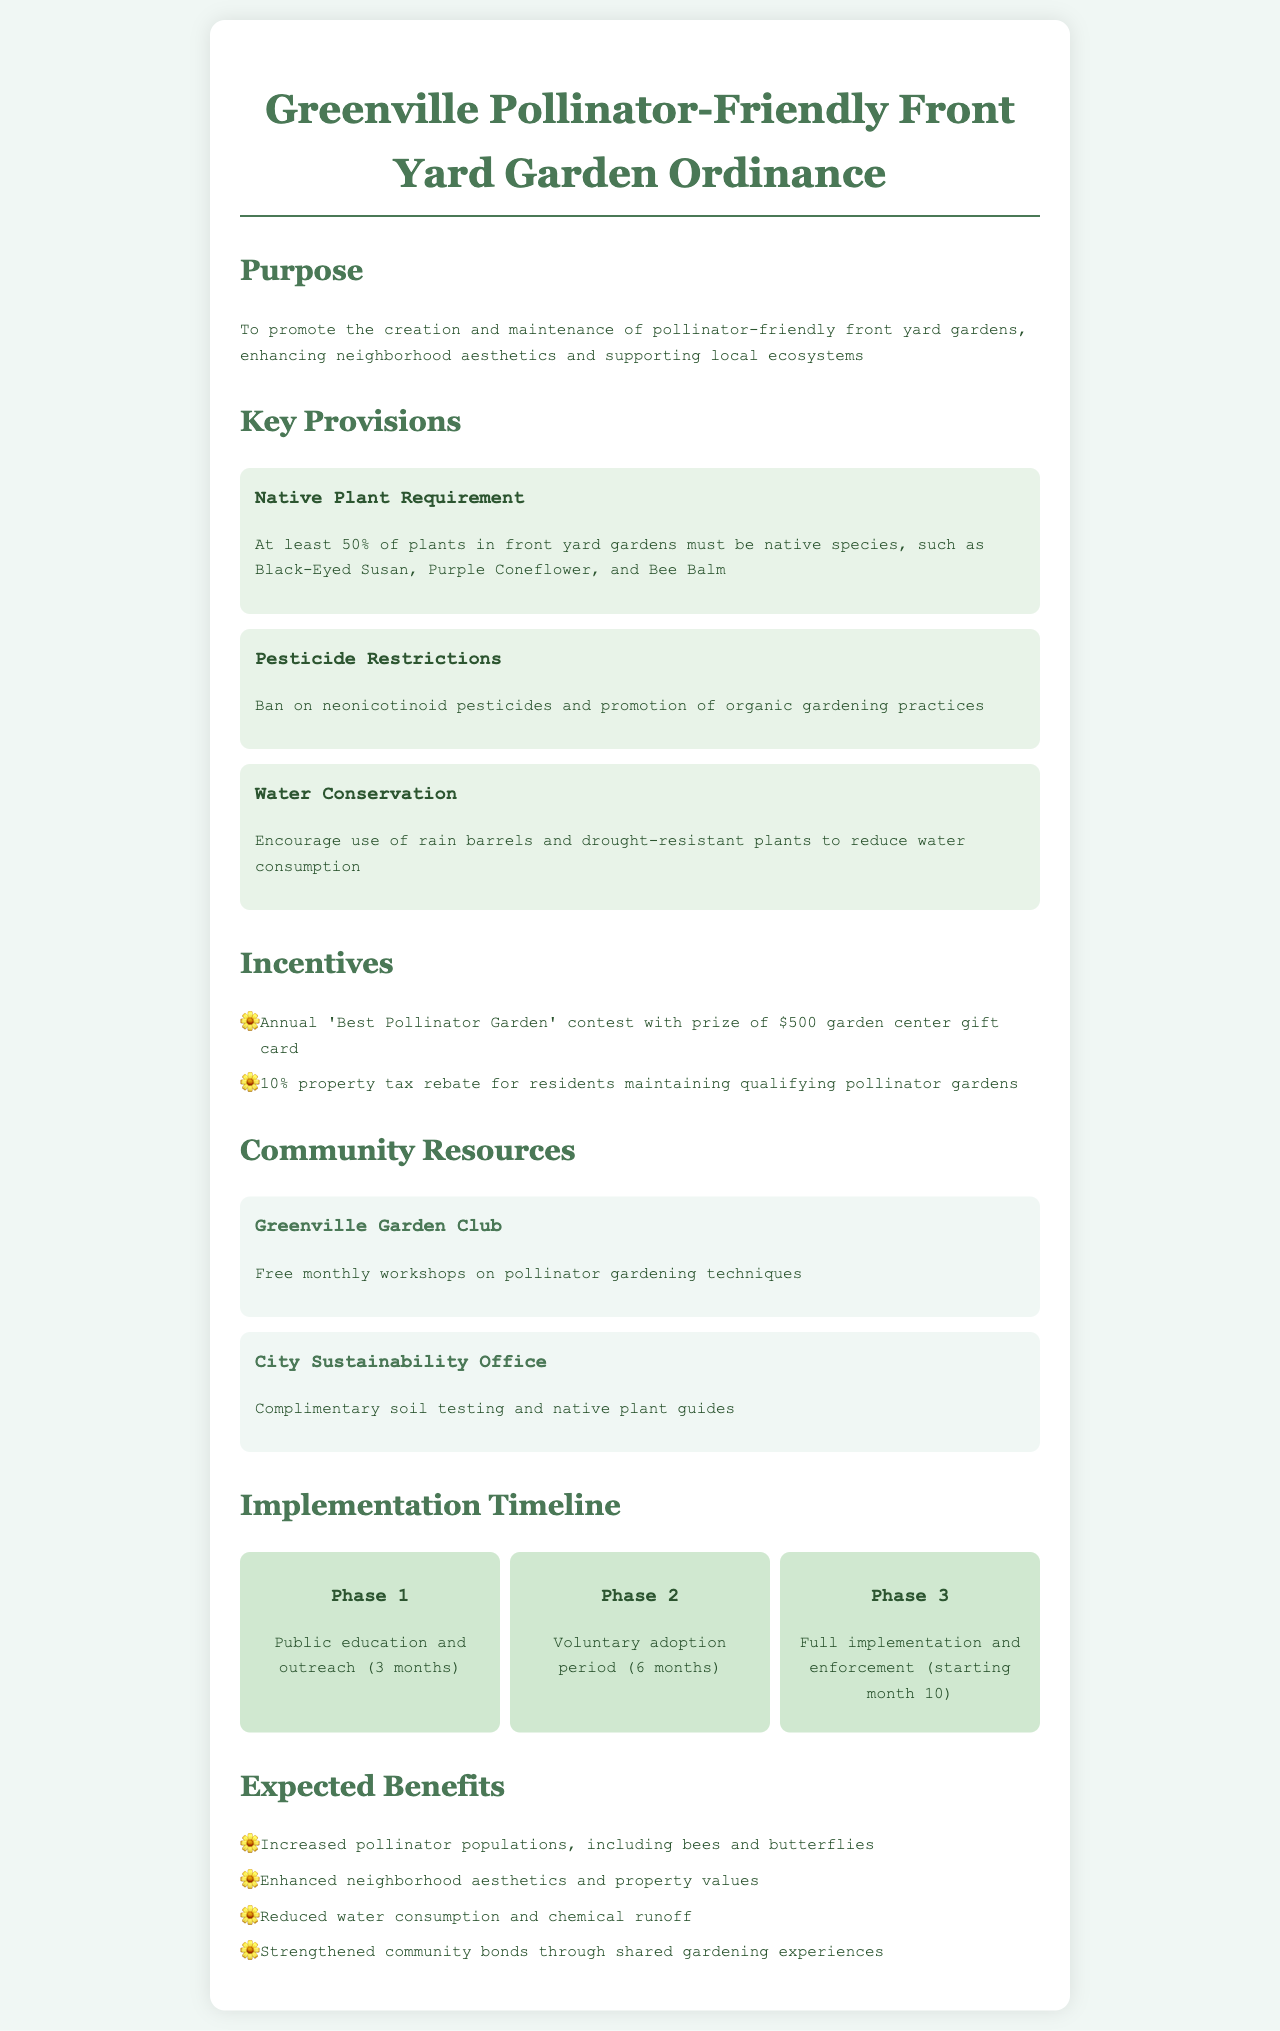What is the main purpose of the ordinance? The purpose is to promote the creation and maintenance of pollinator-friendly front yard gardens, enhancing neighborhood aesthetics and supporting local ecosystems.
Answer: To promote pollinator-friendly gardens What percentage of plants must be native species? The document states that at least 50% of plants in front yard gardens must be native species.
Answer: 50% What kind of pesticides are banned under this ordinance? The ordinance specifically bans neonicotinoid pesticides.
Answer: Neonicotinoid What is the prize for the 'Best Pollinator Garden' contest? The winner of the contest receives a gift card for $500 to a garden center.
Answer: $500 garden center gift card When does full implementation and enforcement begin? Full implementation and enforcement will start in month 10 of the timeline.
Answer: Month 10 What organization offers free monthly workshops on pollinator gardening? The Greenville Garden Club provides free monthly workshops.
Answer: Greenville Garden Club What is one expected benefit of the ordinance? One expected benefit is increased pollinator populations, including bees and butterflies.
Answer: Increased pollinator populations How long is the voluntary adoption period? The voluntary adoption period lasts for 6 months.
Answer: 6 months What resource does the City Sustainability Office provide? The City Sustainability Office offers complimentary soil testing and native plant guides.
Answer: Complimentary soil testing and native plant guides 